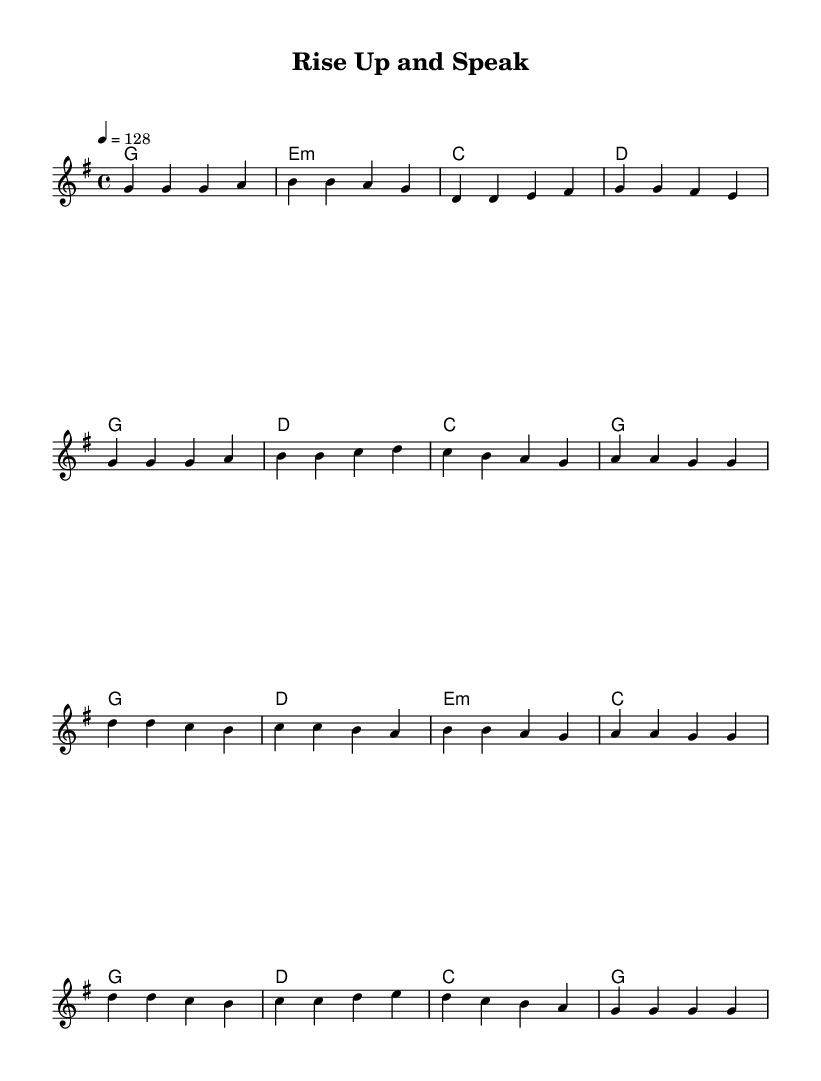What is the key signature of this music? The key signature indicates that the music is in G major, which has one sharp (F#). The presence of the F# in the melody and the chords confirms this key signature.
Answer: G major What is the time signature of this music? The time signature shown at the beginning of the piece is 4/4, meaning there are four beats in each measure and a quarter note gets one beat. This is indicated in the upper left part of the sheet music.
Answer: 4/4 What is the tempo marking of this music? The tempo marking at the beginning indicates a speed of 128 beats per minute. This is noted on the line that shows the tempo, following the "4 = " marker.
Answer: 128 How many measures are in the verse section? The verse section, as indicated by the motifs and section breaks, consists of 8 measures when counting each group of notes in the melody line.
Answer: 8 Which two chords are used in both the verse and the chorus? The chords G and C appear in both the verse and chorus sections, demonstrating their recurrence throughout the piece. Finding them in the chord mode section will confirm their presence.
Answer: G, C What is the highest note in the melody? The highest note in the melody is D5, which appears in the chorus, particularly at the first note of the chorus section. It can be identified by locating the highest pitch mark in the melody line.
Answer: D What musical genre does this piece exemplify? The piece exemplifies pop music, particularly emphasized by its upbeat tempo, repetitive structure, and catchy melodic lines, which are characteristic of popular music aimed at celebration and advocacy.
Answer: Pop 